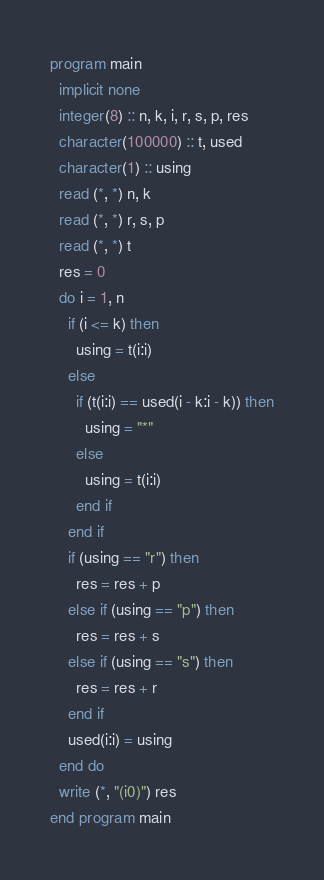<code> <loc_0><loc_0><loc_500><loc_500><_FORTRAN_>program main
  implicit none
  integer(8) :: n, k, i, r, s, p, res
  character(100000) :: t, used
  character(1) :: using
  read (*, *) n, k
  read (*, *) r, s, p
  read (*, *) t
  res = 0
  do i = 1, n
    if (i <= k) then
      using = t(i:i)
    else
      if (t(i:i) == used(i - k:i - k)) then
        using = "*"
      else
        using = t(i:i)
      end if
    end if
    if (using == "r") then
      res = res + p
    else if (using == "p") then
      res = res + s
    else if (using == "s") then
      res = res + r
    end if
    used(i:i) = using
  end do
  write (*, "(i0)") res
end program main
</code> 